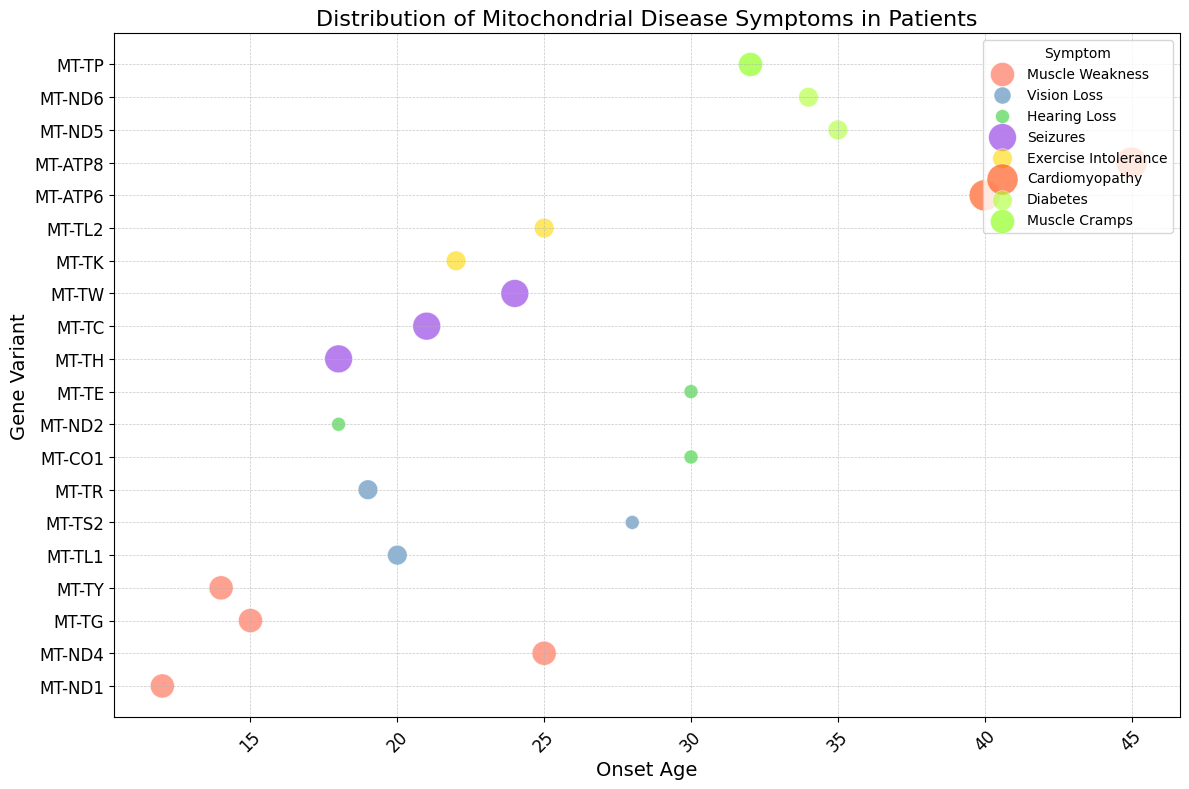Which symptom appears to have the highest severity in the chart? Looking at the size of the bubbles, the largest ones represent the highest severity. The darkest orange bubbles for Cardiomyopathy are the largest.
Answer: Cardiomyopathy Which symptom is most associated with patients having an older onset age? By examining the horizontal axis, the symptom with the largest onset age (ages 40 and 45) is Cardiomyopathy.
Answer: Cardiomyopathy How many symptoms have an onset age of 30 or more? Considering the onset ages on the horizontal axis and counting the bubbles starting at age 30, we find three symptoms: Hearing Loss, Cardiomyopathy, Muscle Cramps.
Answer: 3 What is the gene variant associated with the earliest onset age for Muscle Weakness? Observing the Muscle Weakness colored bubbles and their positions on the x-axis, the earliest onset is at age 12, linked with the gene variant MT-ND1.
Answer: MT-ND1 Which patients (by symptom) have the smallest severity score? To find the smallest bubbles on the chart, look for the size of the bubbles, which are the smallest for Hearing Loss and Vision Loss (1).
Answer: Hearing Loss and Vision Loss Compare the severity of Seizures and Exercise Intolerance. Which one is generally higher? By comparing the size of the bubbles for Seizures (purple) and Exercise Intolerance (yellow), Seizures generally have larger bubbles, indicating a higher severity.
Answer: Seizures How many gene variants are associated with Seizures? Looking at the gene variants on the vertical axis, we see the bubbles for Seizures in purple color align with four gene variants: MT-TH, MT-TC, MT-TW.
Answer: 3 For the symptom Diabetes, at what age does it show up the most, and what is the severity? The green bubbles representing Diabetes appear at ages 34 and 35, both with a severity of 2.
Answer: Age 34 and 35, Severity 2 Which symptom has the most diverse range of onset age? By considering the spread of bubbles horizontally for each symptom, Muscle Weakness appears at ages ranging from 12 to 25, showing significant diversity.
Answer: Muscle Weakness Identify symptoms with a severity score of 3. Looking at the bubbles sizes for an intermediate size (severity score of 3), we see Muscle Weakness and Muscle Cramps.
Answer: Muscle Weakness and Muscle Cramps 